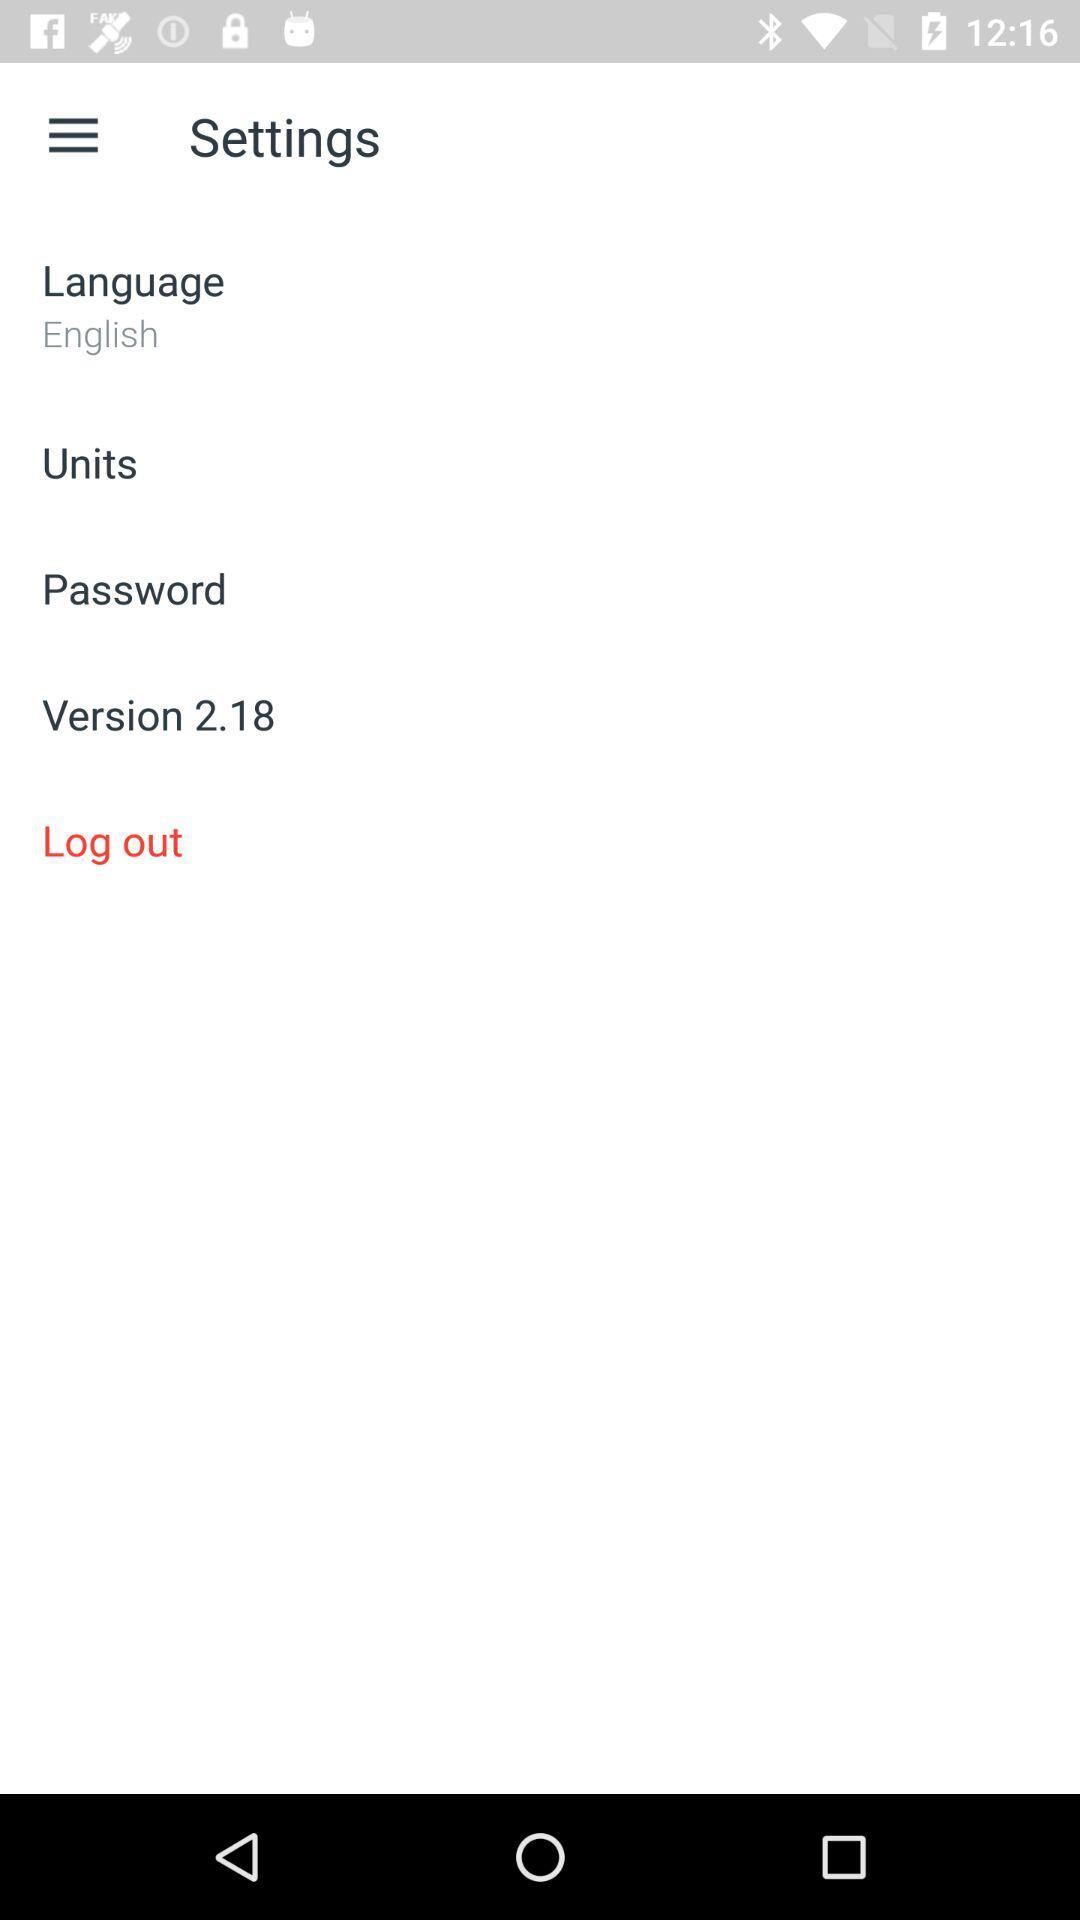What is the selected language? The selected language is English. 